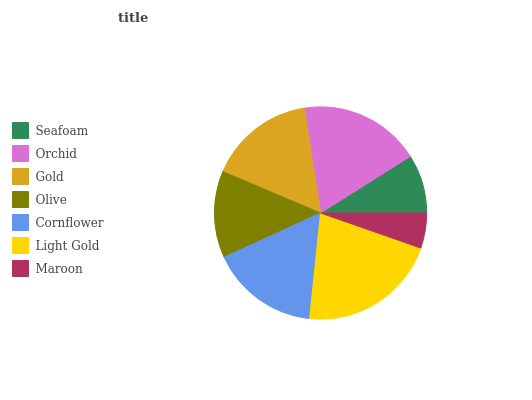Is Maroon the minimum?
Answer yes or no. Yes. Is Light Gold the maximum?
Answer yes or no. Yes. Is Orchid the minimum?
Answer yes or no. No. Is Orchid the maximum?
Answer yes or no. No. Is Orchid greater than Seafoam?
Answer yes or no. Yes. Is Seafoam less than Orchid?
Answer yes or no. Yes. Is Seafoam greater than Orchid?
Answer yes or no. No. Is Orchid less than Seafoam?
Answer yes or no. No. Is Gold the high median?
Answer yes or no. Yes. Is Gold the low median?
Answer yes or no. Yes. Is Seafoam the high median?
Answer yes or no. No. Is Maroon the low median?
Answer yes or no. No. 